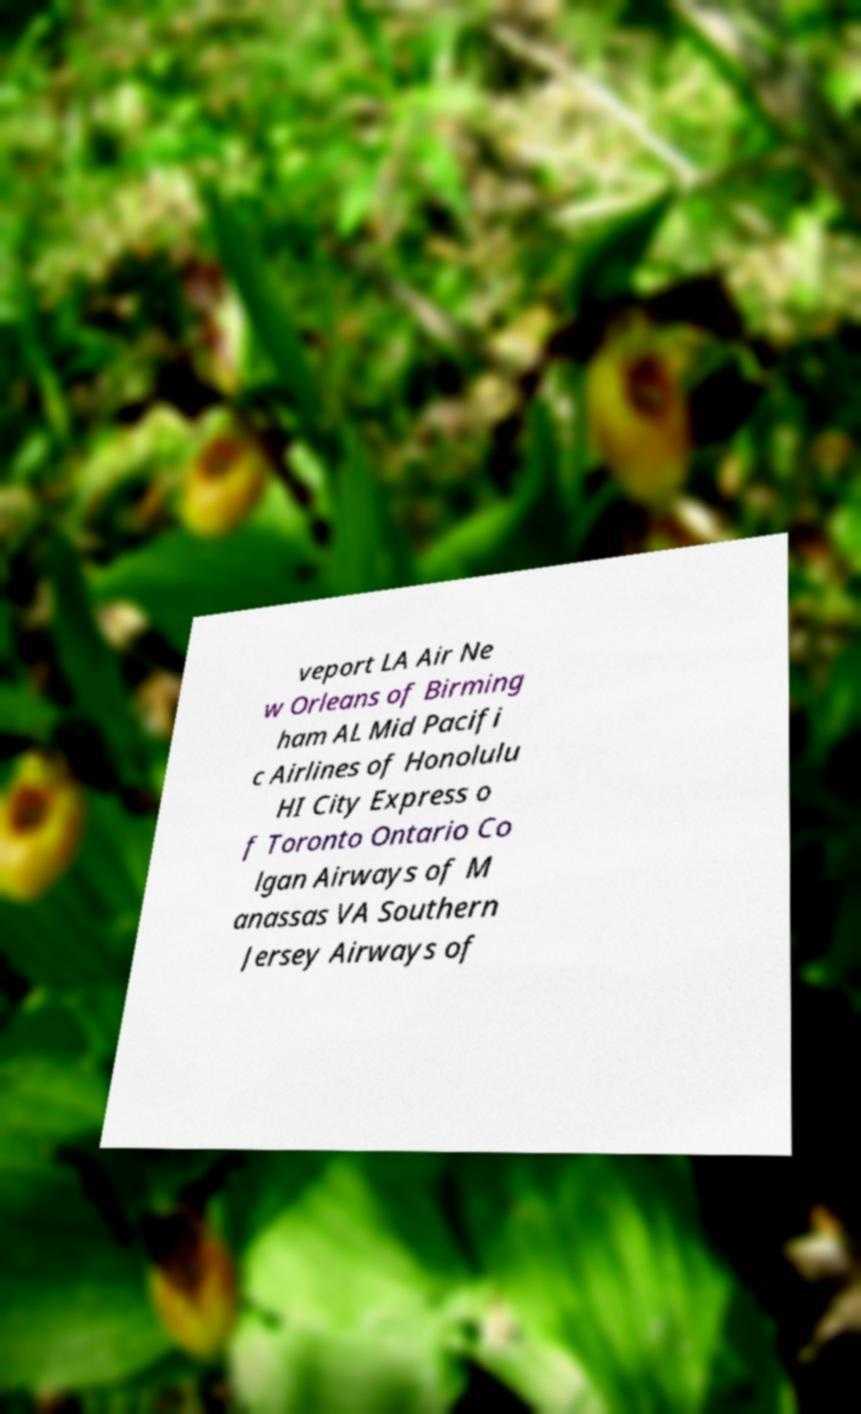Can you accurately transcribe the text from the provided image for me? veport LA Air Ne w Orleans of Birming ham AL Mid Pacifi c Airlines of Honolulu HI City Express o f Toronto Ontario Co lgan Airways of M anassas VA Southern Jersey Airways of 